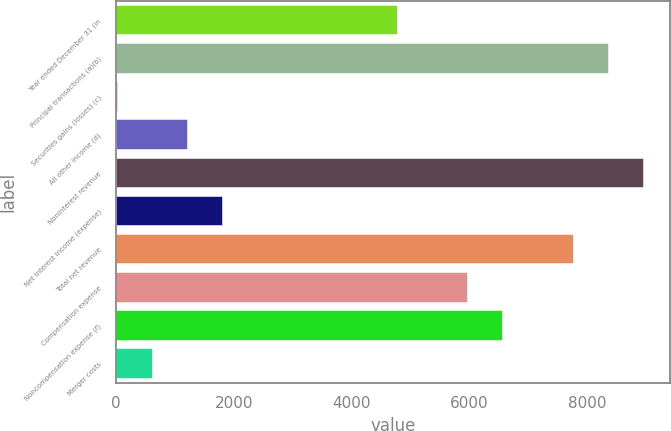Convert chart to OTSL. <chart><loc_0><loc_0><loc_500><loc_500><bar_chart><fcel>Year ended December 31 (in<fcel>Principal transactions (a)(b)<fcel>Securities gains (losses) (c)<fcel>All other income (d)<fcel>Noninterest revenue<fcel>Net interest income (expense)<fcel>Total net revenue<fcel>Compensation expense<fcel>Noncompensation expense (f)<fcel>Merger costs<nl><fcel>4798.2<fcel>8367.6<fcel>39<fcel>1228.8<fcel>8962.5<fcel>1823.7<fcel>7772.7<fcel>5988<fcel>6582.9<fcel>633.9<nl></chart> 